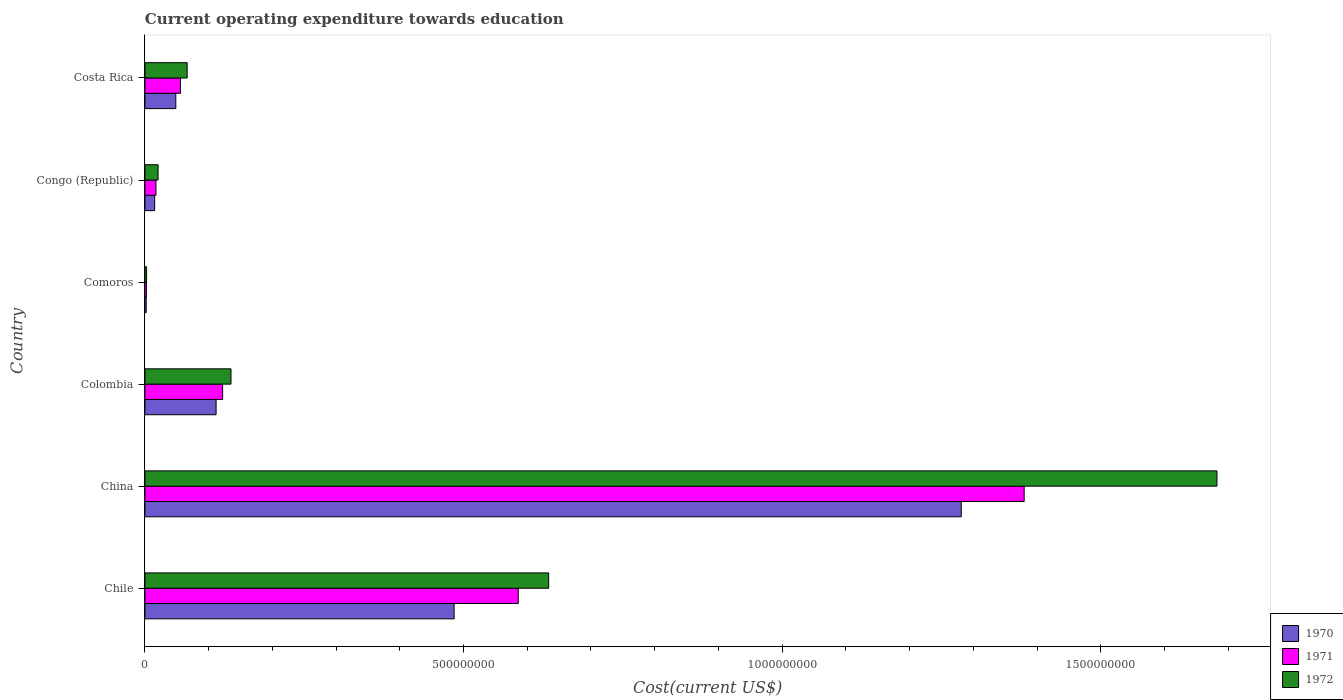How many different coloured bars are there?
Keep it short and to the point. 3. How many groups of bars are there?
Offer a terse response. 6. Are the number of bars per tick equal to the number of legend labels?
Ensure brevity in your answer.  Yes. Are the number of bars on each tick of the Y-axis equal?
Provide a short and direct response. Yes. How many bars are there on the 1st tick from the bottom?
Keep it short and to the point. 3. What is the label of the 4th group of bars from the top?
Your response must be concise. Colombia. What is the expenditure towards education in 1970 in Costa Rica?
Offer a terse response. 4.85e+07. Across all countries, what is the maximum expenditure towards education in 1972?
Offer a very short reply. 1.68e+09. Across all countries, what is the minimum expenditure towards education in 1970?
Offer a terse response. 1.98e+06. In which country was the expenditure towards education in 1971 minimum?
Your answer should be very brief. Comoros. What is the total expenditure towards education in 1970 in the graph?
Give a very brief answer. 1.94e+09. What is the difference between the expenditure towards education in 1972 in Comoros and that in Congo (Republic)?
Keep it short and to the point. -1.80e+07. What is the difference between the expenditure towards education in 1972 in Costa Rica and the expenditure towards education in 1971 in Colombia?
Offer a very short reply. -5.56e+07. What is the average expenditure towards education in 1971 per country?
Ensure brevity in your answer.  3.61e+08. What is the difference between the expenditure towards education in 1972 and expenditure towards education in 1971 in Chile?
Give a very brief answer. 4.77e+07. In how many countries, is the expenditure towards education in 1970 greater than 300000000 US$?
Keep it short and to the point. 2. What is the ratio of the expenditure towards education in 1971 in Colombia to that in Costa Rica?
Give a very brief answer. 2.19. Is the expenditure towards education in 1971 in China less than that in Colombia?
Keep it short and to the point. No. What is the difference between the highest and the second highest expenditure towards education in 1971?
Make the answer very short. 7.94e+08. What is the difference between the highest and the lowest expenditure towards education in 1971?
Your answer should be compact. 1.38e+09. Is the sum of the expenditure towards education in 1972 in Chile and Comoros greater than the maximum expenditure towards education in 1971 across all countries?
Provide a short and direct response. No. What does the 2nd bar from the top in Colombia represents?
Ensure brevity in your answer.  1971. What does the 2nd bar from the bottom in China represents?
Offer a terse response. 1971. Are all the bars in the graph horizontal?
Your answer should be compact. Yes. Are the values on the major ticks of X-axis written in scientific E-notation?
Your answer should be compact. No. Does the graph contain grids?
Offer a terse response. No. Where does the legend appear in the graph?
Ensure brevity in your answer.  Bottom right. How many legend labels are there?
Ensure brevity in your answer.  3. How are the legend labels stacked?
Your response must be concise. Vertical. What is the title of the graph?
Keep it short and to the point. Current operating expenditure towards education. What is the label or title of the X-axis?
Give a very brief answer. Cost(current US$). What is the Cost(current US$) in 1970 in Chile?
Your response must be concise. 4.85e+08. What is the Cost(current US$) of 1971 in Chile?
Offer a very short reply. 5.86e+08. What is the Cost(current US$) of 1972 in Chile?
Give a very brief answer. 6.34e+08. What is the Cost(current US$) in 1970 in China?
Your answer should be very brief. 1.28e+09. What is the Cost(current US$) in 1971 in China?
Your answer should be very brief. 1.38e+09. What is the Cost(current US$) in 1972 in China?
Keep it short and to the point. 1.68e+09. What is the Cost(current US$) in 1970 in Colombia?
Keep it short and to the point. 1.12e+08. What is the Cost(current US$) of 1971 in Colombia?
Your answer should be compact. 1.22e+08. What is the Cost(current US$) of 1972 in Colombia?
Provide a short and direct response. 1.35e+08. What is the Cost(current US$) in 1970 in Comoros?
Offer a very short reply. 1.98e+06. What is the Cost(current US$) in 1971 in Comoros?
Your answer should be compact. 2.34e+06. What is the Cost(current US$) in 1972 in Comoros?
Your response must be concise. 2.64e+06. What is the Cost(current US$) in 1970 in Congo (Republic)?
Keep it short and to the point. 1.53e+07. What is the Cost(current US$) in 1971 in Congo (Republic)?
Offer a very short reply. 1.73e+07. What is the Cost(current US$) of 1972 in Congo (Republic)?
Make the answer very short. 2.06e+07. What is the Cost(current US$) of 1970 in Costa Rica?
Keep it short and to the point. 4.85e+07. What is the Cost(current US$) of 1971 in Costa Rica?
Make the answer very short. 5.58e+07. What is the Cost(current US$) in 1972 in Costa Rica?
Give a very brief answer. 6.63e+07. Across all countries, what is the maximum Cost(current US$) in 1970?
Provide a succinct answer. 1.28e+09. Across all countries, what is the maximum Cost(current US$) in 1971?
Ensure brevity in your answer.  1.38e+09. Across all countries, what is the maximum Cost(current US$) of 1972?
Offer a very short reply. 1.68e+09. Across all countries, what is the minimum Cost(current US$) in 1970?
Offer a very short reply. 1.98e+06. Across all countries, what is the minimum Cost(current US$) of 1971?
Ensure brevity in your answer.  2.34e+06. Across all countries, what is the minimum Cost(current US$) in 1972?
Provide a succinct answer. 2.64e+06. What is the total Cost(current US$) in 1970 in the graph?
Provide a short and direct response. 1.94e+09. What is the total Cost(current US$) in 1971 in the graph?
Provide a succinct answer. 2.16e+09. What is the total Cost(current US$) of 1972 in the graph?
Your answer should be compact. 2.54e+09. What is the difference between the Cost(current US$) in 1970 in Chile and that in China?
Give a very brief answer. -7.96e+08. What is the difference between the Cost(current US$) in 1971 in Chile and that in China?
Your answer should be compact. -7.94e+08. What is the difference between the Cost(current US$) in 1972 in Chile and that in China?
Provide a succinct answer. -1.05e+09. What is the difference between the Cost(current US$) of 1970 in Chile and that in Colombia?
Make the answer very short. 3.74e+08. What is the difference between the Cost(current US$) of 1971 in Chile and that in Colombia?
Make the answer very short. 4.64e+08. What is the difference between the Cost(current US$) of 1972 in Chile and that in Colombia?
Give a very brief answer. 4.99e+08. What is the difference between the Cost(current US$) of 1970 in Chile and that in Comoros?
Keep it short and to the point. 4.83e+08. What is the difference between the Cost(current US$) of 1971 in Chile and that in Comoros?
Ensure brevity in your answer.  5.84e+08. What is the difference between the Cost(current US$) in 1972 in Chile and that in Comoros?
Provide a short and direct response. 6.31e+08. What is the difference between the Cost(current US$) of 1970 in Chile and that in Congo (Republic)?
Make the answer very short. 4.70e+08. What is the difference between the Cost(current US$) in 1971 in Chile and that in Congo (Republic)?
Offer a very short reply. 5.69e+08. What is the difference between the Cost(current US$) of 1972 in Chile and that in Congo (Republic)?
Your answer should be compact. 6.13e+08. What is the difference between the Cost(current US$) of 1970 in Chile and that in Costa Rica?
Offer a terse response. 4.37e+08. What is the difference between the Cost(current US$) in 1971 in Chile and that in Costa Rica?
Give a very brief answer. 5.30e+08. What is the difference between the Cost(current US$) of 1972 in Chile and that in Costa Rica?
Your answer should be compact. 5.67e+08. What is the difference between the Cost(current US$) in 1970 in China and that in Colombia?
Your response must be concise. 1.17e+09. What is the difference between the Cost(current US$) of 1971 in China and that in Colombia?
Your answer should be very brief. 1.26e+09. What is the difference between the Cost(current US$) in 1972 in China and that in Colombia?
Ensure brevity in your answer.  1.55e+09. What is the difference between the Cost(current US$) in 1970 in China and that in Comoros?
Give a very brief answer. 1.28e+09. What is the difference between the Cost(current US$) in 1971 in China and that in Comoros?
Provide a succinct answer. 1.38e+09. What is the difference between the Cost(current US$) in 1972 in China and that in Comoros?
Offer a terse response. 1.68e+09. What is the difference between the Cost(current US$) in 1970 in China and that in Congo (Republic)?
Your response must be concise. 1.27e+09. What is the difference between the Cost(current US$) of 1971 in China and that in Congo (Republic)?
Your response must be concise. 1.36e+09. What is the difference between the Cost(current US$) of 1972 in China and that in Congo (Republic)?
Keep it short and to the point. 1.66e+09. What is the difference between the Cost(current US$) of 1970 in China and that in Costa Rica?
Your answer should be very brief. 1.23e+09. What is the difference between the Cost(current US$) in 1971 in China and that in Costa Rica?
Your response must be concise. 1.32e+09. What is the difference between the Cost(current US$) in 1972 in China and that in Costa Rica?
Make the answer very short. 1.62e+09. What is the difference between the Cost(current US$) in 1970 in Colombia and that in Comoros?
Ensure brevity in your answer.  1.10e+08. What is the difference between the Cost(current US$) in 1971 in Colombia and that in Comoros?
Offer a very short reply. 1.20e+08. What is the difference between the Cost(current US$) of 1972 in Colombia and that in Comoros?
Keep it short and to the point. 1.32e+08. What is the difference between the Cost(current US$) in 1970 in Colombia and that in Congo (Republic)?
Provide a succinct answer. 9.64e+07. What is the difference between the Cost(current US$) in 1971 in Colombia and that in Congo (Republic)?
Your answer should be compact. 1.05e+08. What is the difference between the Cost(current US$) of 1972 in Colombia and that in Congo (Republic)?
Your answer should be very brief. 1.14e+08. What is the difference between the Cost(current US$) of 1970 in Colombia and that in Costa Rica?
Keep it short and to the point. 6.33e+07. What is the difference between the Cost(current US$) in 1971 in Colombia and that in Costa Rica?
Give a very brief answer. 6.62e+07. What is the difference between the Cost(current US$) of 1972 in Colombia and that in Costa Rica?
Give a very brief answer. 6.88e+07. What is the difference between the Cost(current US$) in 1970 in Comoros and that in Congo (Republic)?
Your answer should be very brief. -1.33e+07. What is the difference between the Cost(current US$) of 1971 in Comoros and that in Congo (Republic)?
Offer a terse response. -1.50e+07. What is the difference between the Cost(current US$) of 1972 in Comoros and that in Congo (Republic)?
Give a very brief answer. -1.80e+07. What is the difference between the Cost(current US$) of 1970 in Comoros and that in Costa Rica?
Your answer should be very brief. -4.65e+07. What is the difference between the Cost(current US$) in 1971 in Comoros and that in Costa Rica?
Offer a very short reply. -5.34e+07. What is the difference between the Cost(current US$) in 1972 in Comoros and that in Costa Rica?
Offer a very short reply. -6.36e+07. What is the difference between the Cost(current US$) of 1970 in Congo (Republic) and that in Costa Rica?
Your answer should be very brief. -3.32e+07. What is the difference between the Cost(current US$) of 1971 in Congo (Republic) and that in Costa Rica?
Provide a short and direct response. -3.84e+07. What is the difference between the Cost(current US$) in 1972 in Congo (Republic) and that in Costa Rica?
Make the answer very short. -4.57e+07. What is the difference between the Cost(current US$) of 1970 in Chile and the Cost(current US$) of 1971 in China?
Offer a very short reply. -8.95e+08. What is the difference between the Cost(current US$) of 1970 in Chile and the Cost(current US$) of 1972 in China?
Your answer should be compact. -1.20e+09. What is the difference between the Cost(current US$) in 1971 in Chile and the Cost(current US$) in 1972 in China?
Offer a very short reply. -1.10e+09. What is the difference between the Cost(current US$) of 1970 in Chile and the Cost(current US$) of 1971 in Colombia?
Keep it short and to the point. 3.63e+08. What is the difference between the Cost(current US$) of 1970 in Chile and the Cost(current US$) of 1972 in Colombia?
Offer a terse response. 3.50e+08. What is the difference between the Cost(current US$) in 1971 in Chile and the Cost(current US$) in 1972 in Colombia?
Keep it short and to the point. 4.51e+08. What is the difference between the Cost(current US$) of 1970 in Chile and the Cost(current US$) of 1971 in Comoros?
Make the answer very short. 4.83e+08. What is the difference between the Cost(current US$) in 1970 in Chile and the Cost(current US$) in 1972 in Comoros?
Ensure brevity in your answer.  4.83e+08. What is the difference between the Cost(current US$) in 1971 in Chile and the Cost(current US$) in 1972 in Comoros?
Offer a terse response. 5.83e+08. What is the difference between the Cost(current US$) of 1970 in Chile and the Cost(current US$) of 1971 in Congo (Republic)?
Give a very brief answer. 4.68e+08. What is the difference between the Cost(current US$) in 1970 in Chile and the Cost(current US$) in 1972 in Congo (Republic)?
Ensure brevity in your answer.  4.65e+08. What is the difference between the Cost(current US$) of 1971 in Chile and the Cost(current US$) of 1972 in Congo (Republic)?
Offer a terse response. 5.65e+08. What is the difference between the Cost(current US$) in 1970 in Chile and the Cost(current US$) in 1971 in Costa Rica?
Your answer should be compact. 4.29e+08. What is the difference between the Cost(current US$) of 1970 in Chile and the Cost(current US$) of 1972 in Costa Rica?
Offer a terse response. 4.19e+08. What is the difference between the Cost(current US$) of 1971 in Chile and the Cost(current US$) of 1972 in Costa Rica?
Ensure brevity in your answer.  5.20e+08. What is the difference between the Cost(current US$) of 1970 in China and the Cost(current US$) of 1971 in Colombia?
Give a very brief answer. 1.16e+09. What is the difference between the Cost(current US$) of 1970 in China and the Cost(current US$) of 1972 in Colombia?
Offer a very short reply. 1.15e+09. What is the difference between the Cost(current US$) of 1971 in China and the Cost(current US$) of 1972 in Colombia?
Provide a short and direct response. 1.24e+09. What is the difference between the Cost(current US$) in 1970 in China and the Cost(current US$) in 1971 in Comoros?
Provide a short and direct response. 1.28e+09. What is the difference between the Cost(current US$) in 1970 in China and the Cost(current US$) in 1972 in Comoros?
Your answer should be compact. 1.28e+09. What is the difference between the Cost(current US$) of 1971 in China and the Cost(current US$) of 1972 in Comoros?
Offer a very short reply. 1.38e+09. What is the difference between the Cost(current US$) in 1970 in China and the Cost(current US$) in 1971 in Congo (Republic)?
Provide a short and direct response. 1.26e+09. What is the difference between the Cost(current US$) of 1970 in China and the Cost(current US$) of 1972 in Congo (Republic)?
Offer a very short reply. 1.26e+09. What is the difference between the Cost(current US$) in 1971 in China and the Cost(current US$) in 1972 in Congo (Republic)?
Make the answer very short. 1.36e+09. What is the difference between the Cost(current US$) of 1970 in China and the Cost(current US$) of 1971 in Costa Rica?
Keep it short and to the point. 1.23e+09. What is the difference between the Cost(current US$) in 1970 in China and the Cost(current US$) in 1972 in Costa Rica?
Make the answer very short. 1.21e+09. What is the difference between the Cost(current US$) in 1971 in China and the Cost(current US$) in 1972 in Costa Rica?
Offer a very short reply. 1.31e+09. What is the difference between the Cost(current US$) in 1970 in Colombia and the Cost(current US$) in 1971 in Comoros?
Offer a terse response. 1.09e+08. What is the difference between the Cost(current US$) in 1970 in Colombia and the Cost(current US$) in 1972 in Comoros?
Make the answer very short. 1.09e+08. What is the difference between the Cost(current US$) of 1971 in Colombia and the Cost(current US$) of 1972 in Comoros?
Provide a succinct answer. 1.19e+08. What is the difference between the Cost(current US$) of 1970 in Colombia and the Cost(current US$) of 1971 in Congo (Republic)?
Provide a short and direct response. 9.44e+07. What is the difference between the Cost(current US$) of 1970 in Colombia and the Cost(current US$) of 1972 in Congo (Republic)?
Your answer should be very brief. 9.11e+07. What is the difference between the Cost(current US$) of 1971 in Colombia and the Cost(current US$) of 1972 in Congo (Republic)?
Your answer should be very brief. 1.01e+08. What is the difference between the Cost(current US$) in 1970 in Colombia and the Cost(current US$) in 1971 in Costa Rica?
Provide a short and direct response. 5.59e+07. What is the difference between the Cost(current US$) in 1970 in Colombia and the Cost(current US$) in 1972 in Costa Rica?
Make the answer very short. 4.54e+07. What is the difference between the Cost(current US$) of 1971 in Colombia and the Cost(current US$) of 1972 in Costa Rica?
Provide a short and direct response. 5.56e+07. What is the difference between the Cost(current US$) in 1970 in Comoros and the Cost(current US$) in 1971 in Congo (Republic)?
Ensure brevity in your answer.  -1.53e+07. What is the difference between the Cost(current US$) in 1970 in Comoros and the Cost(current US$) in 1972 in Congo (Republic)?
Make the answer very short. -1.86e+07. What is the difference between the Cost(current US$) of 1971 in Comoros and the Cost(current US$) of 1972 in Congo (Republic)?
Make the answer very short. -1.83e+07. What is the difference between the Cost(current US$) in 1970 in Comoros and the Cost(current US$) in 1971 in Costa Rica?
Your response must be concise. -5.38e+07. What is the difference between the Cost(current US$) of 1970 in Comoros and the Cost(current US$) of 1972 in Costa Rica?
Your response must be concise. -6.43e+07. What is the difference between the Cost(current US$) of 1971 in Comoros and the Cost(current US$) of 1972 in Costa Rica?
Give a very brief answer. -6.39e+07. What is the difference between the Cost(current US$) in 1970 in Congo (Republic) and the Cost(current US$) in 1971 in Costa Rica?
Give a very brief answer. -4.05e+07. What is the difference between the Cost(current US$) of 1970 in Congo (Republic) and the Cost(current US$) of 1972 in Costa Rica?
Make the answer very short. -5.10e+07. What is the difference between the Cost(current US$) in 1971 in Congo (Republic) and the Cost(current US$) in 1972 in Costa Rica?
Provide a succinct answer. -4.89e+07. What is the average Cost(current US$) of 1970 per country?
Offer a very short reply. 3.24e+08. What is the average Cost(current US$) in 1971 per country?
Your response must be concise. 3.61e+08. What is the average Cost(current US$) of 1972 per country?
Offer a very short reply. 4.23e+08. What is the difference between the Cost(current US$) of 1970 and Cost(current US$) of 1971 in Chile?
Ensure brevity in your answer.  -1.01e+08. What is the difference between the Cost(current US$) in 1970 and Cost(current US$) in 1972 in Chile?
Offer a terse response. -1.48e+08. What is the difference between the Cost(current US$) of 1971 and Cost(current US$) of 1972 in Chile?
Ensure brevity in your answer.  -4.77e+07. What is the difference between the Cost(current US$) of 1970 and Cost(current US$) of 1971 in China?
Provide a short and direct response. -9.88e+07. What is the difference between the Cost(current US$) of 1970 and Cost(current US$) of 1972 in China?
Offer a very short reply. -4.01e+08. What is the difference between the Cost(current US$) in 1971 and Cost(current US$) in 1972 in China?
Keep it short and to the point. -3.03e+08. What is the difference between the Cost(current US$) of 1970 and Cost(current US$) of 1971 in Colombia?
Keep it short and to the point. -1.02e+07. What is the difference between the Cost(current US$) of 1970 and Cost(current US$) of 1972 in Colombia?
Provide a succinct answer. -2.34e+07. What is the difference between the Cost(current US$) of 1971 and Cost(current US$) of 1972 in Colombia?
Make the answer very short. -1.32e+07. What is the difference between the Cost(current US$) of 1970 and Cost(current US$) of 1971 in Comoros?
Make the answer very short. -3.52e+05. What is the difference between the Cost(current US$) of 1970 and Cost(current US$) of 1972 in Comoros?
Your answer should be compact. -6.53e+05. What is the difference between the Cost(current US$) in 1971 and Cost(current US$) in 1972 in Comoros?
Your response must be concise. -3.01e+05. What is the difference between the Cost(current US$) of 1970 and Cost(current US$) of 1971 in Congo (Republic)?
Provide a succinct answer. -2.05e+06. What is the difference between the Cost(current US$) in 1970 and Cost(current US$) in 1972 in Congo (Republic)?
Offer a very short reply. -5.34e+06. What is the difference between the Cost(current US$) in 1971 and Cost(current US$) in 1972 in Congo (Republic)?
Offer a terse response. -3.29e+06. What is the difference between the Cost(current US$) in 1970 and Cost(current US$) in 1971 in Costa Rica?
Provide a succinct answer. -7.31e+06. What is the difference between the Cost(current US$) in 1970 and Cost(current US$) in 1972 in Costa Rica?
Provide a short and direct response. -1.78e+07. What is the difference between the Cost(current US$) of 1971 and Cost(current US$) of 1972 in Costa Rica?
Your answer should be compact. -1.05e+07. What is the ratio of the Cost(current US$) of 1970 in Chile to that in China?
Your response must be concise. 0.38. What is the ratio of the Cost(current US$) in 1971 in Chile to that in China?
Ensure brevity in your answer.  0.42. What is the ratio of the Cost(current US$) of 1972 in Chile to that in China?
Ensure brevity in your answer.  0.38. What is the ratio of the Cost(current US$) in 1970 in Chile to that in Colombia?
Your response must be concise. 4.34. What is the ratio of the Cost(current US$) of 1971 in Chile to that in Colombia?
Provide a short and direct response. 4.81. What is the ratio of the Cost(current US$) in 1972 in Chile to that in Colombia?
Your response must be concise. 4.69. What is the ratio of the Cost(current US$) in 1970 in Chile to that in Comoros?
Your answer should be very brief. 244.51. What is the ratio of the Cost(current US$) of 1971 in Chile to that in Comoros?
Ensure brevity in your answer.  250.81. What is the ratio of the Cost(current US$) of 1972 in Chile to that in Comoros?
Provide a succinct answer. 240.25. What is the ratio of the Cost(current US$) in 1970 in Chile to that in Congo (Republic)?
Offer a very short reply. 31.75. What is the ratio of the Cost(current US$) in 1971 in Chile to that in Congo (Republic)?
Your response must be concise. 33.81. What is the ratio of the Cost(current US$) in 1972 in Chile to that in Congo (Republic)?
Give a very brief answer. 30.72. What is the ratio of the Cost(current US$) of 1970 in Chile to that in Costa Rica?
Offer a very short reply. 10.01. What is the ratio of the Cost(current US$) in 1971 in Chile to that in Costa Rica?
Offer a terse response. 10.51. What is the ratio of the Cost(current US$) in 1972 in Chile to that in Costa Rica?
Make the answer very short. 9.56. What is the ratio of the Cost(current US$) of 1970 in China to that in Colombia?
Keep it short and to the point. 11.47. What is the ratio of the Cost(current US$) of 1971 in China to that in Colombia?
Offer a very short reply. 11.32. What is the ratio of the Cost(current US$) of 1972 in China to that in Colombia?
Give a very brief answer. 12.45. What is the ratio of the Cost(current US$) of 1970 in China to that in Comoros?
Your answer should be compact. 645.54. What is the ratio of the Cost(current US$) of 1971 in China to that in Comoros?
Provide a short and direct response. 590.68. What is the ratio of the Cost(current US$) in 1972 in China to that in Comoros?
Your response must be concise. 637.94. What is the ratio of the Cost(current US$) in 1970 in China to that in Congo (Republic)?
Your answer should be compact. 83.81. What is the ratio of the Cost(current US$) of 1971 in China to that in Congo (Republic)?
Keep it short and to the point. 79.62. What is the ratio of the Cost(current US$) in 1972 in China to that in Congo (Republic)?
Offer a very short reply. 81.58. What is the ratio of the Cost(current US$) of 1970 in China to that in Costa Rica?
Make the answer very short. 26.44. What is the ratio of the Cost(current US$) in 1971 in China to that in Costa Rica?
Your answer should be compact. 24.75. What is the ratio of the Cost(current US$) in 1972 in China to that in Costa Rica?
Provide a short and direct response. 25.38. What is the ratio of the Cost(current US$) of 1970 in Colombia to that in Comoros?
Give a very brief answer. 56.29. What is the ratio of the Cost(current US$) in 1971 in Colombia to that in Comoros?
Ensure brevity in your answer.  52.19. What is the ratio of the Cost(current US$) in 1972 in Colombia to that in Comoros?
Give a very brief answer. 51.22. What is the ratio of the Cost(current US$) in 1970 in Colombia to that in Congo (Republic)?
Your answer should be compact. 7.31. What is the ratio of the Cost(current US$) in 1971 in Colombia to that in Congo (Republic)?
Offer a terse response. 7.03. What is the ratio of the Cost(current US$) in 1972 in Colombia to that in Congo (Republic)?
Your answer should be compact. 6.55. What is the ratio of the Cost(current US$) of 1970 in Colombia to that in Costa Rica?
Offer a terse response. 2.31. What is the ratio of the Cost(current US$) of 1971 in Colombia to that in Costa Rica?
Provide a succinct answer. 2.19. What is the ratio of the Cost(current US$) of 1972 in Colombia to that in Costa Rica?
Your answer should be compact. 2.04. What is the ratio of the Cost(current US$) of 1970 in Comoros to that in Congo (Republic)?
Your response must be concise. 0.13. What is the ratio of the Cost(current US$) of 1971 in Comoros to that in Congo (Republic)?
Provide a short and direct response. 0.13. What is the ratio of the Cost(current US$) of 1972 in Comoros to that in Congo (Republic)?
Ensure brevity in your answer.  0.13. What is the ratio of the Cost(current US$) of 1970 in Comoros to that in Costa Rica?
Keep it short and to the point. 0.04. What is the ratio of the Cost(current US$) in 1971 in Comoros to that in Costa Rica?
Your answer should be very brief. 0.04. What is the ratio of the Cost(current US$) of 1972 in Comoros to that in Costa Rica?
Your answer should be compact. 0.04. What is the ratio of the Cost(current US$) in 1970 in Congo (Republic) to that in Costa Rica?
Offer a very short reply. 0.32. What is the ratio of the Cost(current US$) of 1971 in Congo (Republic) to that in Costa Rica?
Offer a terse response. 0.31. What is the ratio of the Cost(current US$) of 1972 in Congo (Republic) to that in Costa Rica?
Provide a succinct answer. 0.31. What is the difference between the highest and the second highest Cost(current US$) of 1970?
Your answer should be compact. 7.96e+08. What is the difference between the highest and the second highest Cost(current US$) of 1971?
Provide a succinct answer. 7.94e+08. What is the difference between the highest and the second highest Cost(current US$) in 1972?
Your answer should be compact. 1.05e+09. What is the difference between the highest and the lowest Cost(current US$) in 1970?
Provide a short and direct response. 1.28e+09. What is the difference between the highest and the lowest Cost(current US$) in 1971?
Provide a short and direct response. 1.38e+09. What is the difference between the highest and the lowest Cost(current US$) of 1972?
Make the answer very short. 1.68e+09. 